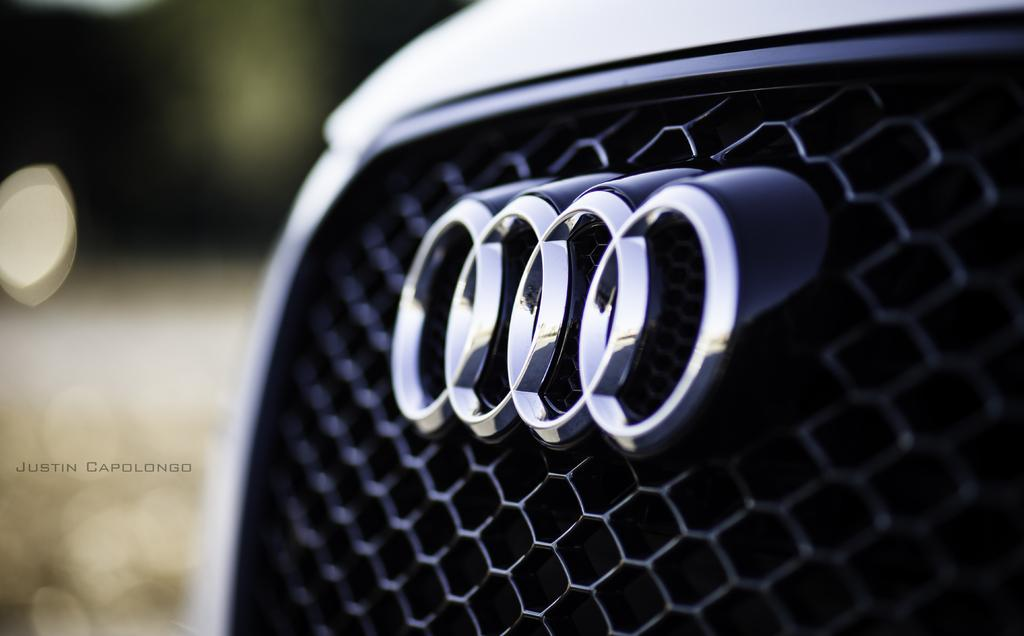What is the main subject of the image? There is a vehicle in the image. Can you describe the color of the vehicle? The vehicle is white in color. What can be observed about the background of the image? The background of the image is blurred. What type of meat can be seen hanging from the vehicle in the image? There is no meat present in the image; it features a white vehicle with a blurred background. 